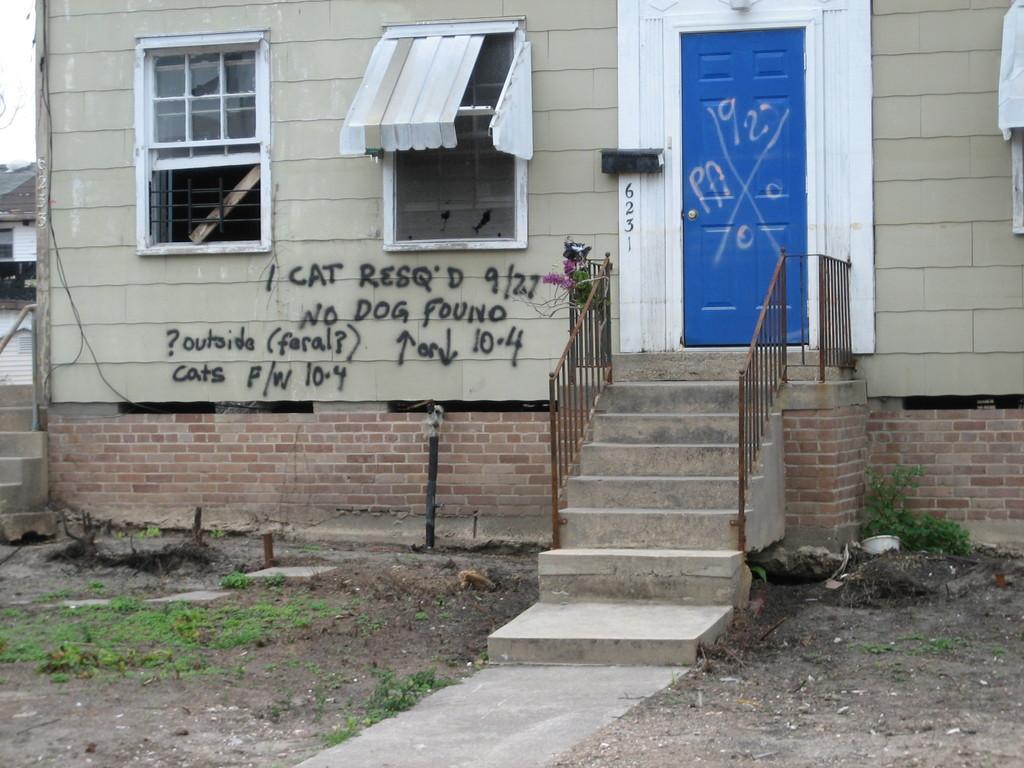How would you summarize this image in a sentence or two? In this picture I can observe a building. In the middle of the picture I can observe small staircase and a blue color door. I can observe black color text on the wall of the building. 